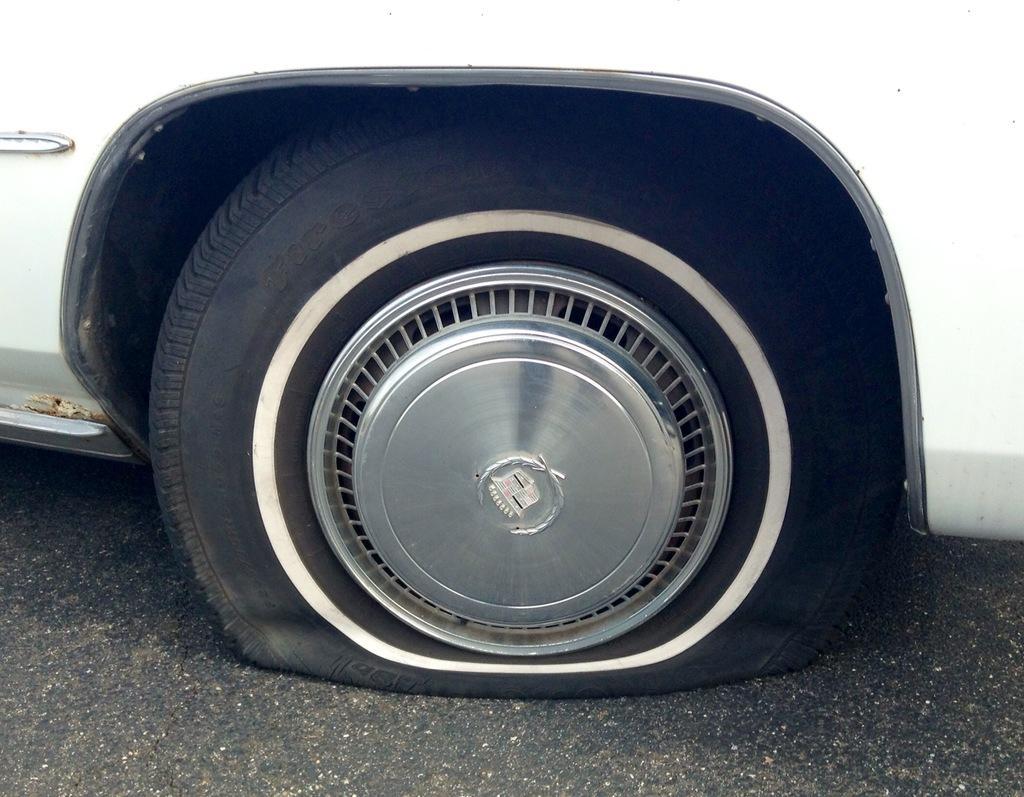Please provide a concise description of this image. In this picture, we see a white car. In the middle of the picture, we see the tyre of the car which is punctured. At the bottom, we see the road. 